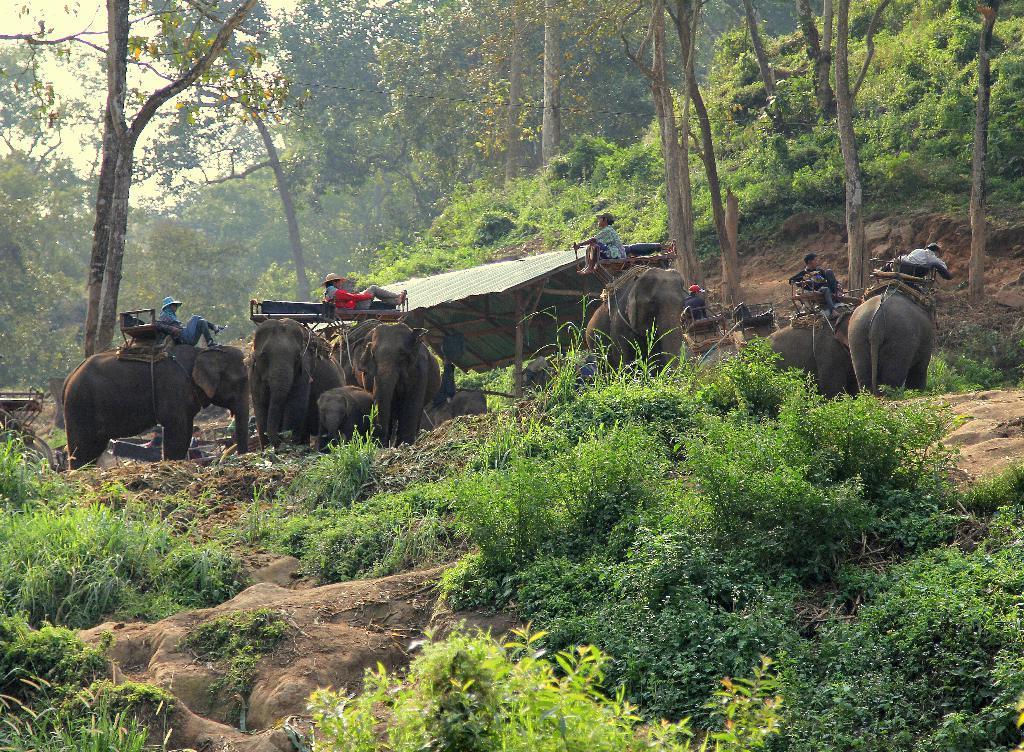How would you summarize this image in a sentence or two? There are few elephants where few persons are sitting on it and there are trees and small plants in the background. 